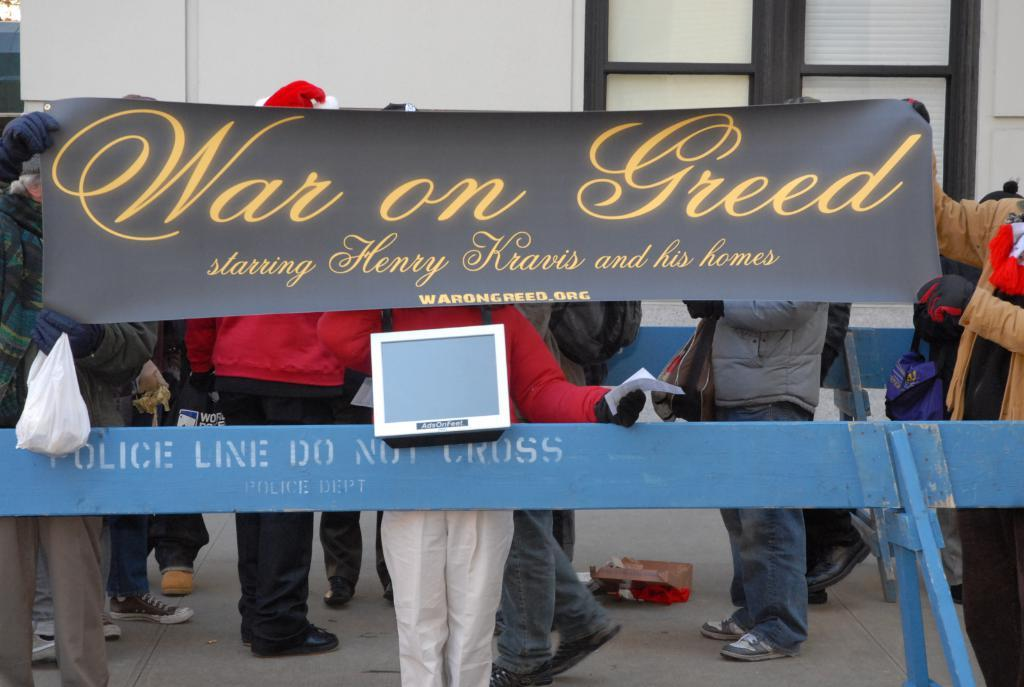How many people can be seen in the image? There are many people standing in the image. What is in front of the people? There is a railing in front of the people. What are the people holding in the image? The people are holding a banner. What can be read on the banner? There is text on the banner. What can be seen in the background of the image? There is a wall in the background of the image. Are there any deer visible in the garden behind the people in the image? There is no garden or deer present in the image. 